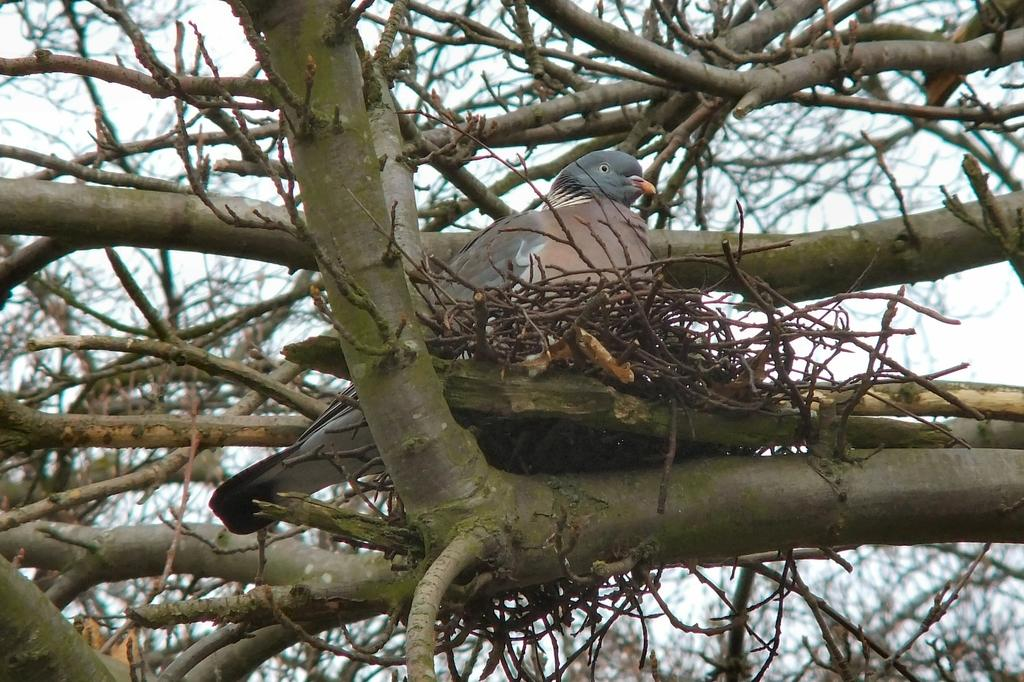What is located in the middle of the picture? There is a bird and a nest in the middle of the picture. What type of natural habitat is depicted in the image? The image features trees in both the foreground and background, suggesting a wooded area. What can be seen in the sky in the background of the picture? The sky is visible in the background of the picture. What type of zephyr is blowing through the bird's nest in the image? There is no mention of a zephyr or any wind in the image; it simply shows a bird and a nest in a wooded area. Can you tell if the bird is writing a message in the image? There is no indication that the bird is writing anything in the image; it is simply perched in its nest. 